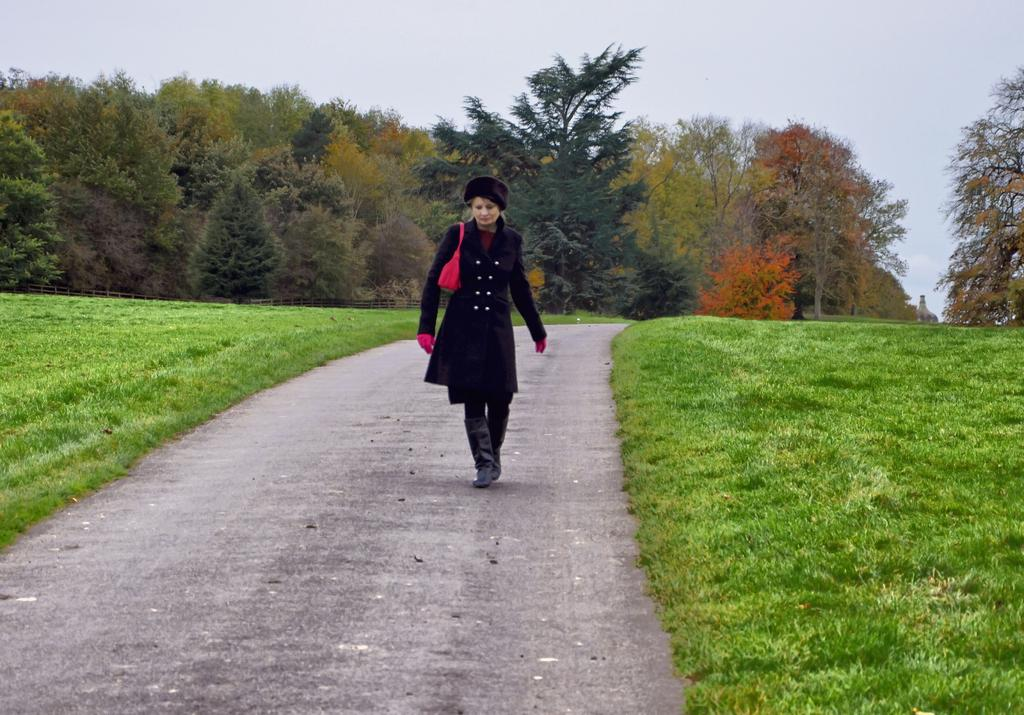What type of vegetation is present in the image? There is grass in the image. What other natural elements can be seen in the image? There are trees in the image. Can you describe the woman in the image? The woman is wearing a black dress and is walking. What is visible at the top of the image? The sky is visible at the top of the image. What note is the woman playing on her blade in the image? There is no note or blade present in the image. The woman is simply walking in a grassy area with trees and a visible sky. 